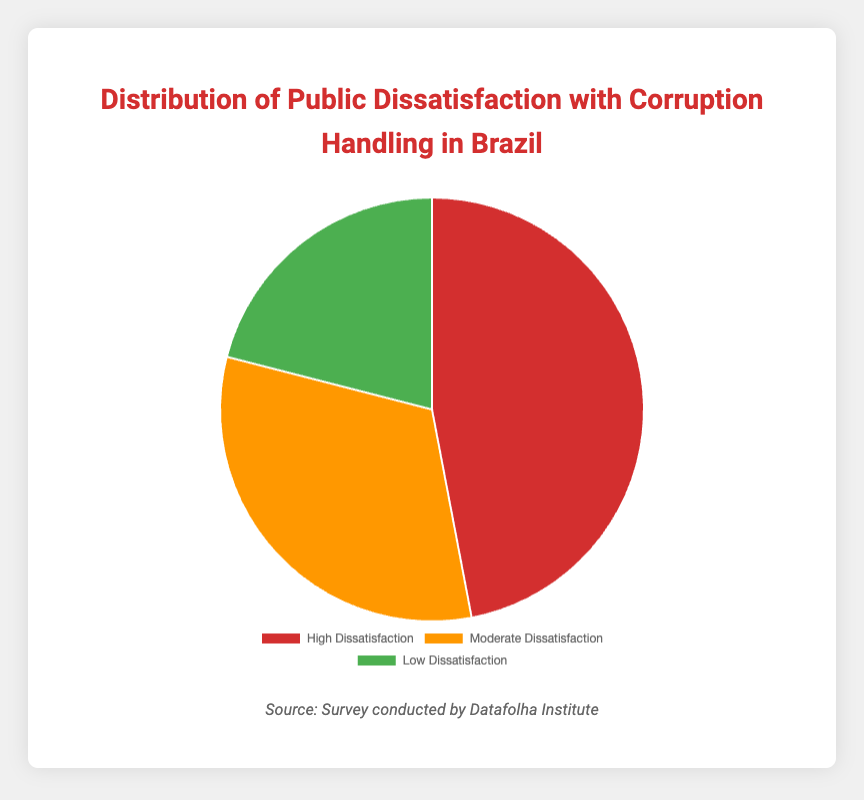What percentage of the surveyed people have low dissatisfaction with corruption handling? The segment labeled "Low Dissatisfaction" shows 21%.
Answer: 21% Which category shows the highest level of public dissatisfaction with how corruption is handled? The category labeled "High Dissatisfaction" has the largest percentage at 47%.
Answer: High Dissatisfaction By how many percentage points does moderate dissatisfaction exceed low dissatisfaction? Moderate dissatisfaction is 32%, and low dissatisfaction is 21%, so the difference is 32% - 21%.
Answer: 11 What is the combined percentage of people with moderate and low dissatisfaction? The sum of moderate dissatisfaction (32%) and low dissatisfaction (21%) is 32% + 21%.
Answer: 53% Which color represents the category with the highest dissatisfaction? The segment labeled "High Dissatisfaction" is colored red.
Answer: Red Considering high and moderate dissatisfaction together, how many times greater is high dissatisfaction compared to low dissatisfaction? The sum of high (47%) and moderate dissatisfaction (32%) is 79%. High dissatisfaction (47%) is (47 / 21) ≈ 2.24 times greater than low dissatisfaction.
Answer: Approximately 2.24 How much more is the percentage of high dissatisfaction compared to the lowest dissatisfaction category? High dissatisfaction (47%) compared to low dissatisfaction (21%), so the difference is 47% - 21%.
Answer: 26 If you were to rank the dissatisfaction levels from highest to lowest, what would be the order? The order from highest to lowest is "High Dissatisfaction" at 47%, followed by "Moderate Dissatisfaction" at 32%, and "Low Dissatisfaction" at 21%.
Answer: High > Moderate > Low 